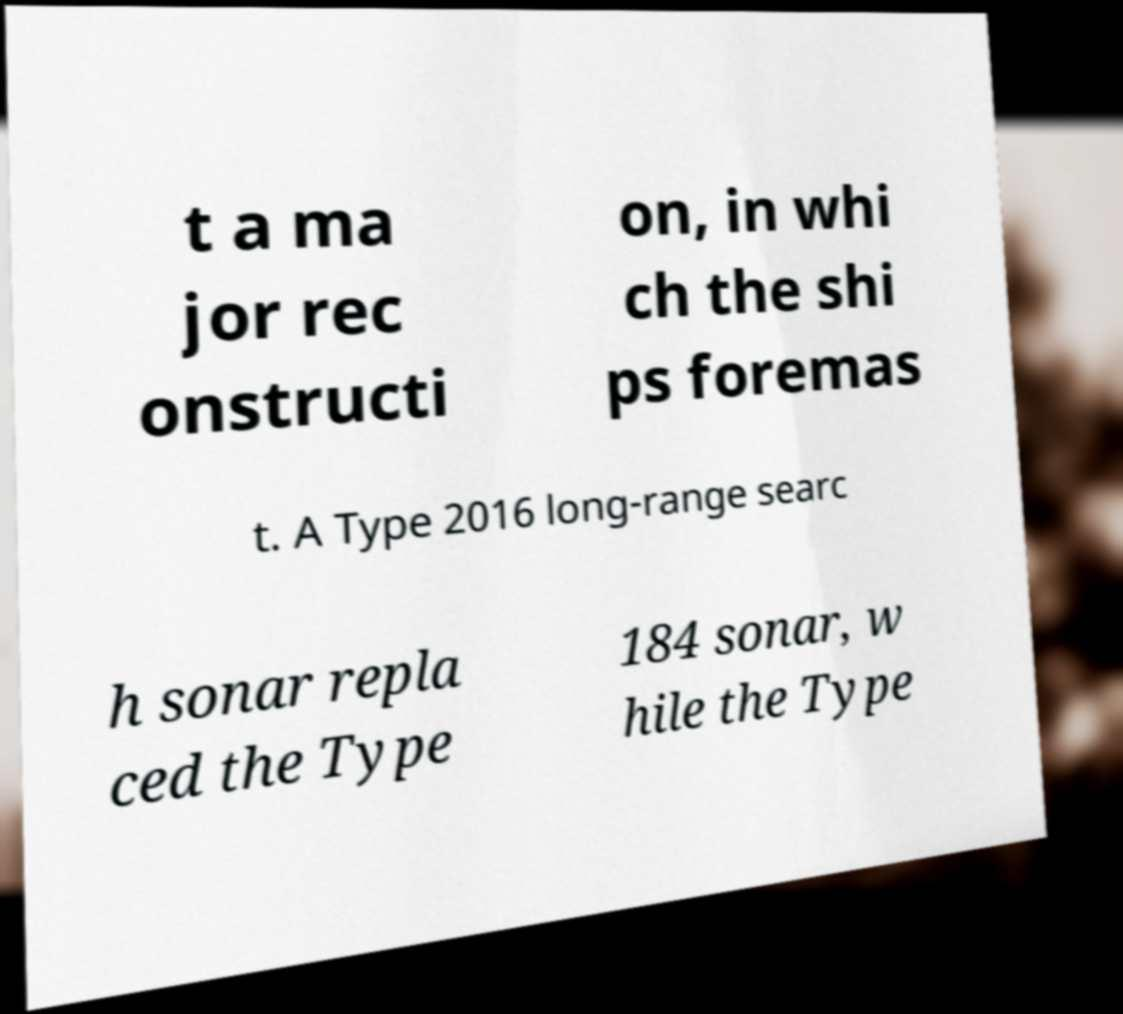Please read and relay the text visible in this image. What does it say? t a ma jor rec onstructi on, in whi ch the shi ps foremas t. A Type 2016 long-range searc h sonar repla ced the Type 184 sonar, w hile the Type 